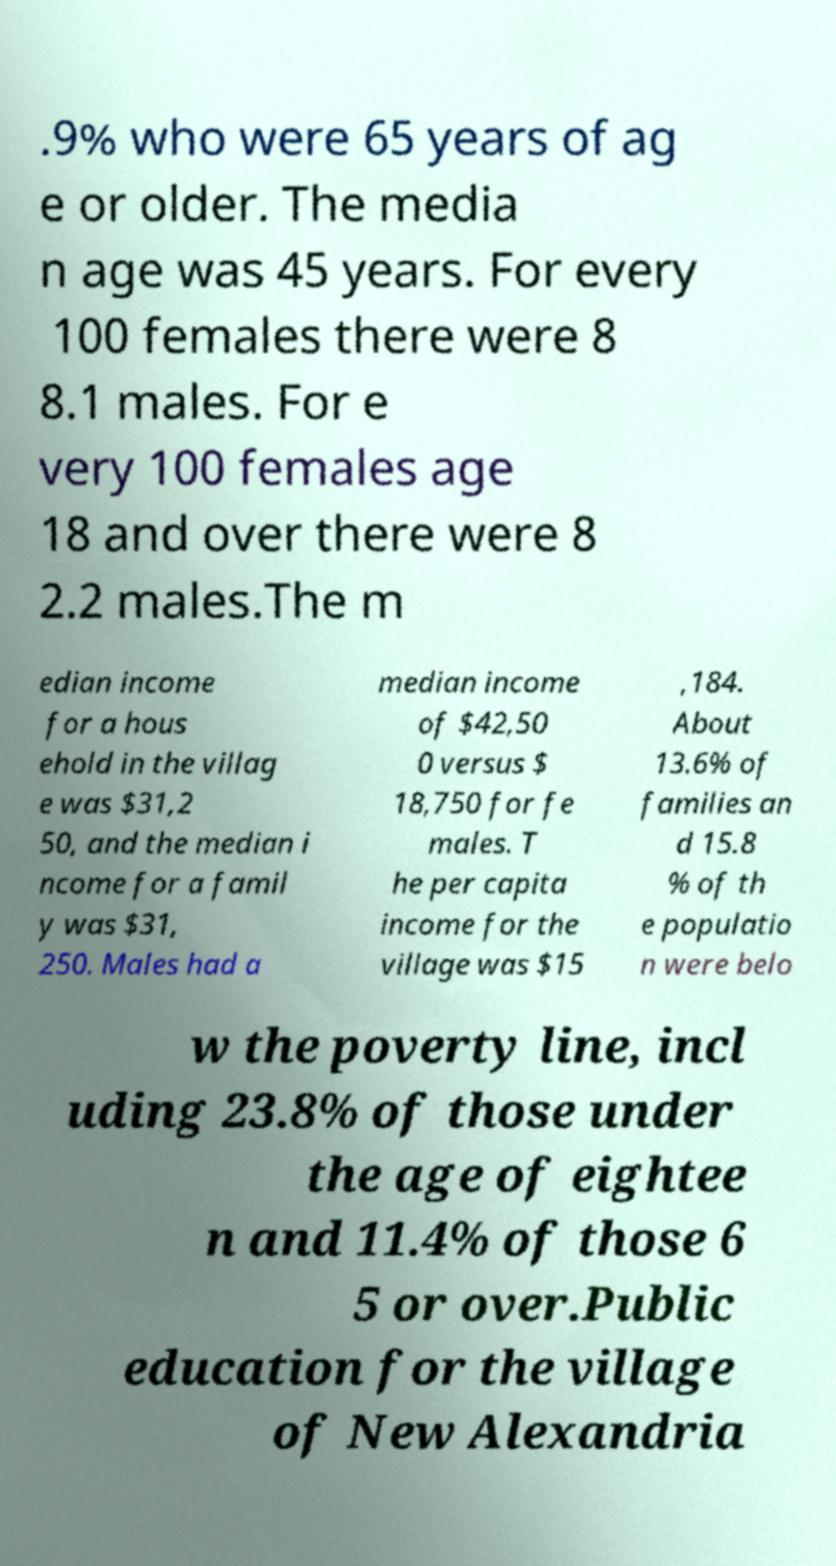Can you read and provide the text displayed in the image?This photo seems to have some interesting text. Can you extract and type it out for me? .9% who were 65 years of ag e or older. The media n age was 45 years. For every 100 females there were 8 8.1 males. For e very 100 females age 18 and over there were 8 2.2 males.The m edian income for a hous ehold in the villag e was $31,2 50, and the median i ncome for a famil y was $31, 250. Males had a median income of $42,50 0 versus $ 18,750 for fe males. T he per capita income for the village was $15 ,184. About 13.6% of families an d 15.8 % of th e populatio n were belo w the poverty line, incl uding 23.8% of those under the age of eightee n and 11.4% of those 6 5 or over.Public education for the village of New Alexandria 